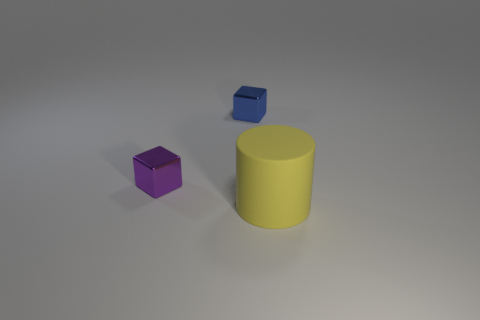How many other things are there of the same material as the tiny purple cube?
Your answer should be compact. 1. There is a matte object that is on the right side of the tiny object to the right of the tiny shiny object in front of the blue object; what color is it?
Make the answer very short. Yellow. What is the shape of the big yellow matte thing in front of the block in front of the tiny blue shiny block?
Give a very brief answer. Cylinder. Are there more yellow cylinders to the left of the large yellow matte cylinder than tiny shiny things?
Your answer should be compact. No. Do the small thing to the left of the blue thing and the blue object have the same shape?
Your response must be concise. Yes. Is there a tiny blue metallic thing that has the same shape as the big yellow matte object?
Provide a short and direct response. No. What number of objects are either things left of the large rubber thing or tiny metal blocks?
Your answer should be compact. 2. Are there more blue objects than large red metal objects?
Your answer should be very brief. Yes. Is there a purple metallic cube that has the same size as the blue object?
Give a very brief answer. Yes. How many objects are tiny metal blocks that are in front of the blue object or objects that are on the right side of the purple block?
Offer a terse response. 3. 